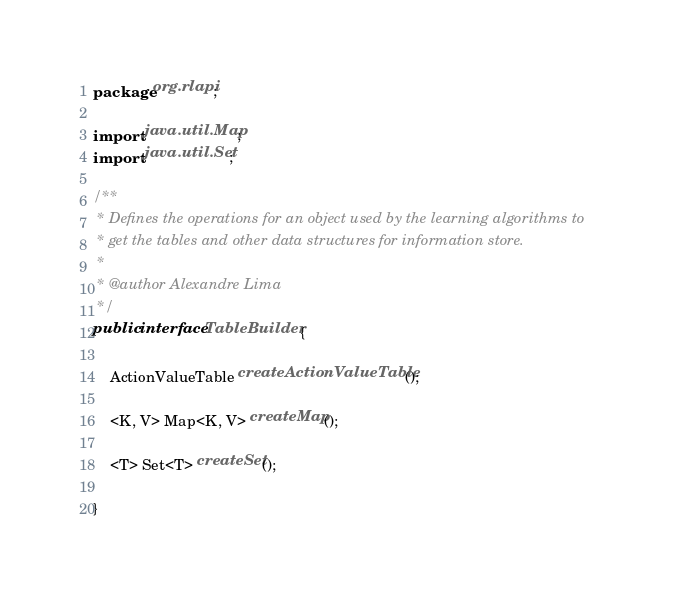Convert code to text. <code><loc_0><loc_0><loc_500><loc_500><_Java_>package org.rlapi;

import java.util.Map;
import java.util.Set;

/**
 * Defines the operations for an object used by the learning algorithms to 
 * get the tables and other data structures for information store.
 * 
 * @author Alexandre Lima
 */
public interface TableBuilder {
    
    ActionValueTable createActionValueTable();
    
    <K, V> Map<K, V> createMap();

    <T> Set<T> createSet();
    
}
</code> 